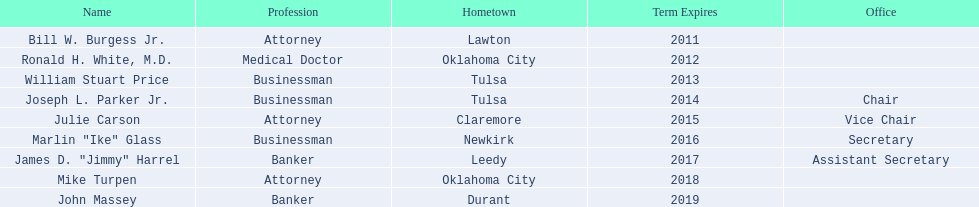Which regents hail from tulsa? William Stuart Price, Joseph L. Parker Jr. Among them, who is not joseph parker jr.? William Stuart Price. 